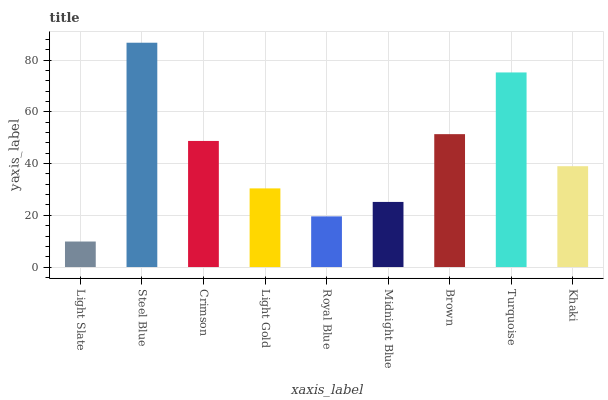Is Light Slate the minimum?
Answer yes or no. Yes. Is Steel Blue the maximum?
Answer yes or no. Yes. Is Crimson the minimum?
Answer yes or no. No. Is Crimson the maximum?
Answer yes or no. No. Is Steel Blue greater than Crimson?
Answer yes or no. Yes. Is Crimson less than Steel Blue?
Answer yes or no. Yes. Is Crimson greater than Steel Blue?
Answer yes or no. No. Is Steel Blue less than Crimson?
Answer yes or no. No. Is Khaki the high median?
Answer yes or no. Yes. Is Khaki the low median?
Answer yes or no. Yes. Is Crimson the high median?
Answer yes or no. No. Is Crimson the low median?
Answer yes or no. No. 